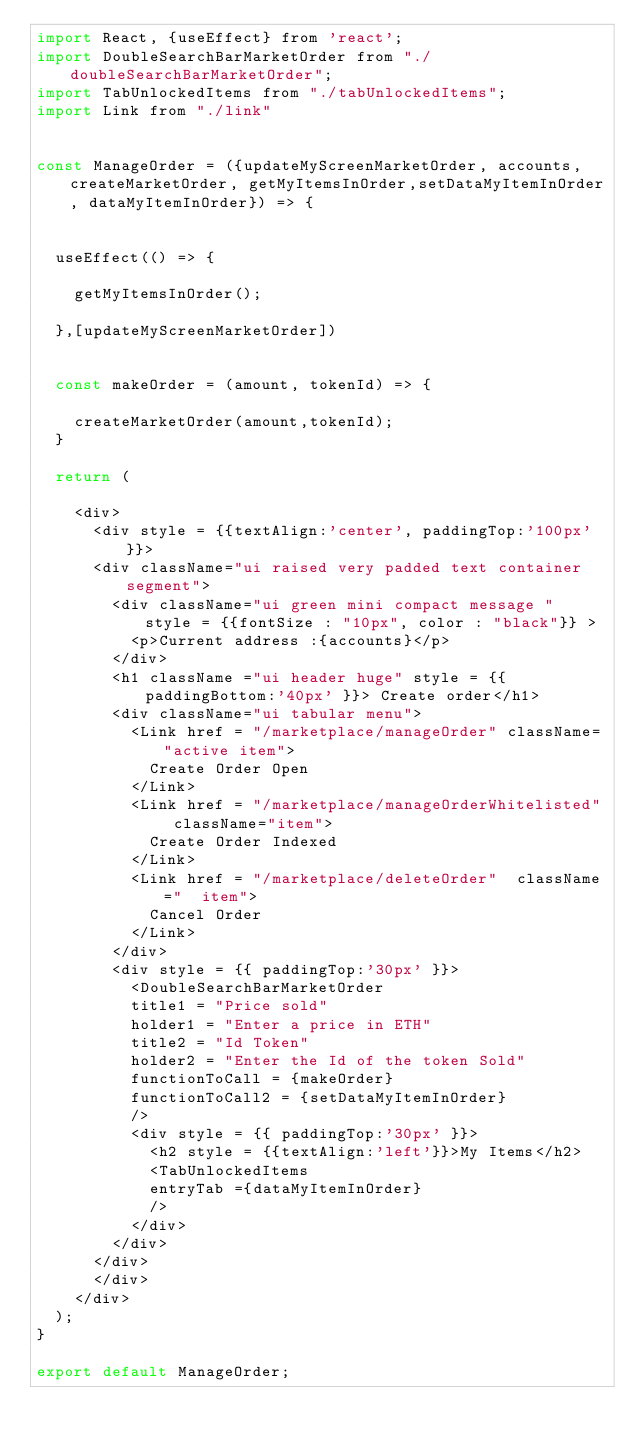Convert code to text. <code><loc_0><loc_0><loc_500><loc_500><_JavaScript_>import React, {useEffect} from 'react';
import DoubleSearchBarMarketOrder from "./doubleSearchBarMarketOrder";
import TabUnlockedItems from "./tabUnlockedItems";
import Link from "./link"


const ManageOrder = ({updateMyScreenMarketOrder, accounts,createMarketOrder, getMyItemsInOrder,setDataMyItemInOrder, dataMyItemInOrder}) => {


	useEffect(() => {

		getMyItemsInOrder();
		
	},[updateMyScreenMarketOrder])


	const makeOrder = (amount, tokenId) => {

		createMarketOrder(amount,tokenId);
	}
	
	return (

		<div>
			<div style = {{textAlign:'center', paddingTop:'100px' }}>
			<div className="ui raised very padded text container segment">
				<div className="ui green mini compact message " style = {{fontSize : "10px", color : "black"}} >
				  <p>Current address :{accounts}</p>
				</div>
				<h1 className ="ui header huge" style = {{paddingBottom:'40px' }}> Create order</h1>
				<div className="ui tabular menu">
				  <Link href = "/marketplace/manageOrder" className="active item">
				    Create Order Open
				  </Link>
				  <Link href = "/marketplace/manageOrderWhitelisted" className="item">
				    Create Order Indexed
				  </Link>
				  <Link href = "/marketplace/deleteOrder"  className="  item">
				    Cancel Order
				  </Link>
				</div>
				<div style = {{ paddingTop:'30px' }}>
					<DoubleSearchBarMarketOrder 
					title1 = "Price sold"
					holder1 = "Enter a price in ETH"
					title2 = "Id Token"
					holder2 = "Enter the Id of the token Sold"
					functionToCall = {makeOrder}
					functionToCall2 = {setDataMyItemInOrder} 
					/>
					<div style = {{ paddingTop:'30px' }}>
						<h2 style = {{textAlign:'left'}}>My Items</h2>
						<TabUnlockedItems
						entryTab ={dataMyItemInOrder}
						/>
					</div>
				</div>
			</div> 
			</div>
		</div>
	);
}

export default ManageOrder;</code> 